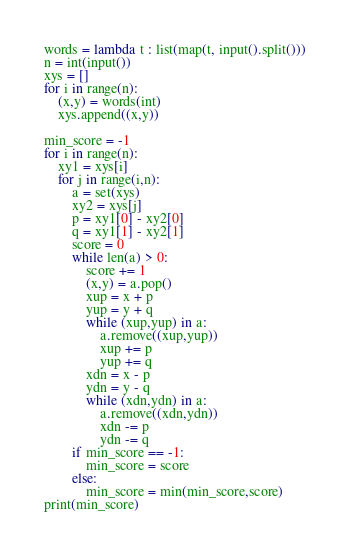Convert code to text. <code><loc_0><loc_0><loc_500><loc_500><_Python_>words = lambda t : list(map(t, input().split()))
n = int(input())
xys = []
for i in range(n):
    (x,y) = words(int)
    xys.append((x,y))

min_score = -1
for i in range(n):
    xy1 = xys[i]
    for j in range(i,n):
        a = set(xys)
        xy2 = xys[j]
        p = xy1[0] - xy2[0]
        q = xy1[1] - xy2[1]
        score = 0
        while len(a) > 0:
            score += 1
            (x,y) = a.pop()
            xup = x + p
            yup = y + q
            while (xup,yup) in a:
                a.remove((xup,yup))
                xup += p
                yup += q
            xdn = x - p
            ydn = y - q
            while (xdn,ydn) in a:
                a.remove((xdn,ydn))
                xdn -= p
                ydn -= q
        if min_score == -1:
            min_score = score
        else:
            min_score = min(min_score,score)
print(min_score)
</code> 